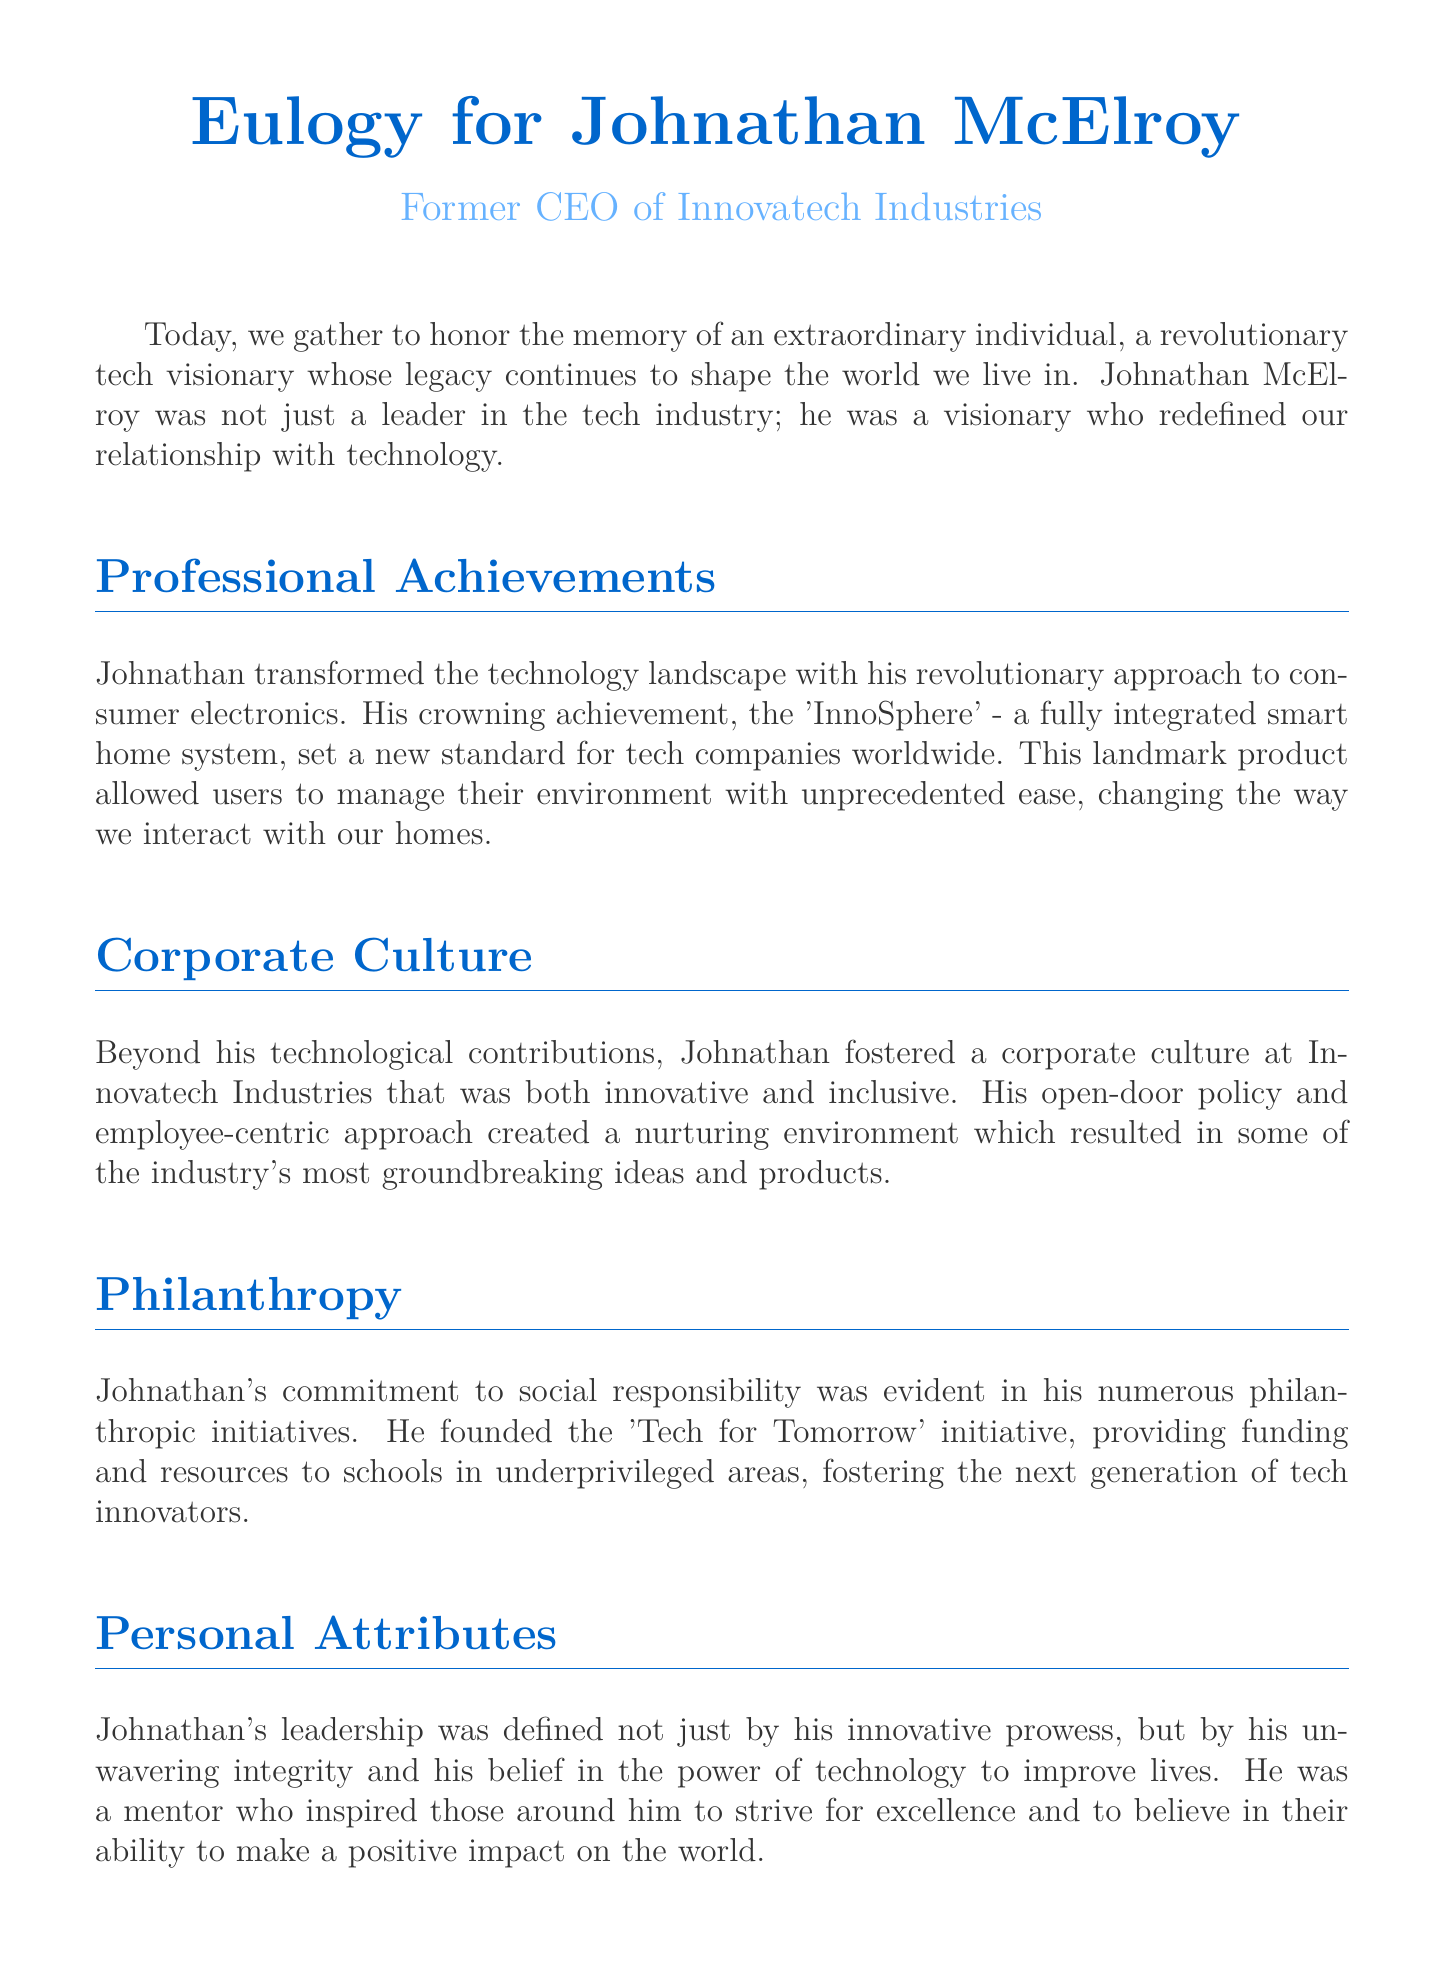What is the name of the visionary being honored? The document mentions Johnathan McElroy as the individual being honored.
Answer: Johnathan McElroy What was Johnathan's role at Innovatech Industries? The document states that he was the former CEO of Innovatech Industries.
Answer: Former CEO What was Johnathan's crowning achievement? The document describes the 'InnoSphere' as Johnathan's crowning achievement.
Answer: InnoSphere What initiative did Johnathan found for social responsibility? The document refers to the 'Tech for Tomorrow' initiative as the one he founded.
Answer: Tech for Tomorrow What was key to Johnathan’s corporate culture? The document highlights his open-door policy and employee-centric approach as key elements of his corporate culture.
Answer: Open-door policy What attribute characterized Johnathan's leadership? The document states that unwavering integrity characterized Johnathan's leadership.
Answer: Unwavering integrity What lasting impact did Johnathan have on the tech industry? The document explains that his impact will be felt for generations.
Answer: Felt for generations Which product changed how users interact with their homes? According to the document, the 'InnoSphere' changed how users interact with their homes.
Answer: InnoSphere What sentiment does the document express about remembering Johnathan? The document expresses a desire to uphold his legacy.
Answer: Uphold his legacy 